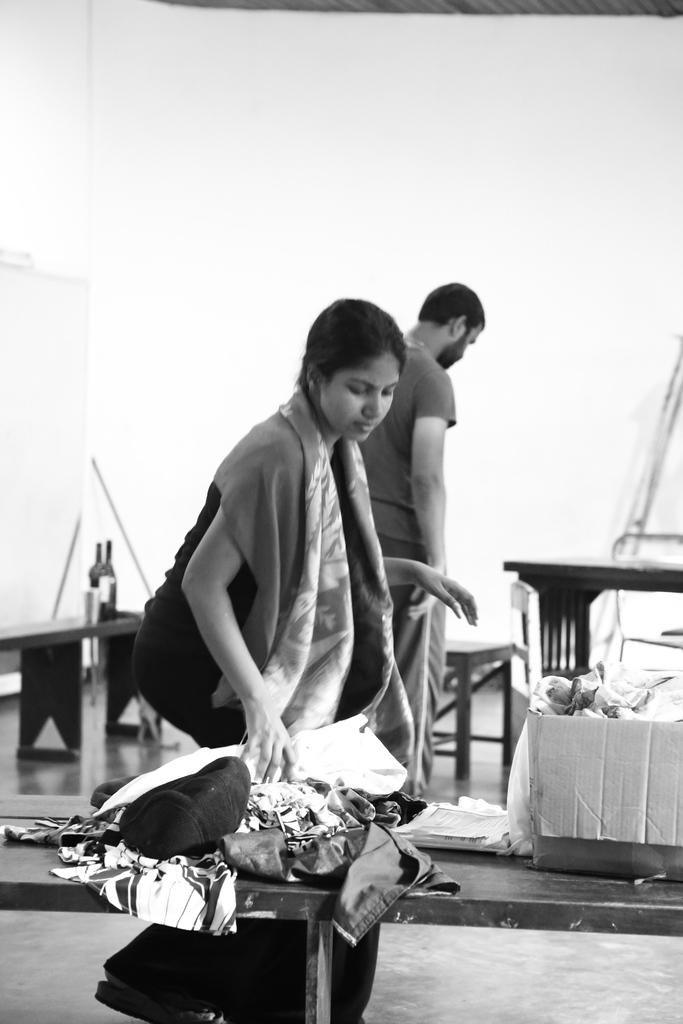Who are the people in the image? There is a girl and a man in the image. What are the girl and man doing in the image? The girl and man are standing. What is on the table in the image? Clothes are placed on the table. What is in front of the table in the image? There is a box in front of the table. What can be seen in the background of the image? There is a wall in the background of the image. What type of berry is being used as a representative for the cow in the image? There is no berry or cow present in the image. 